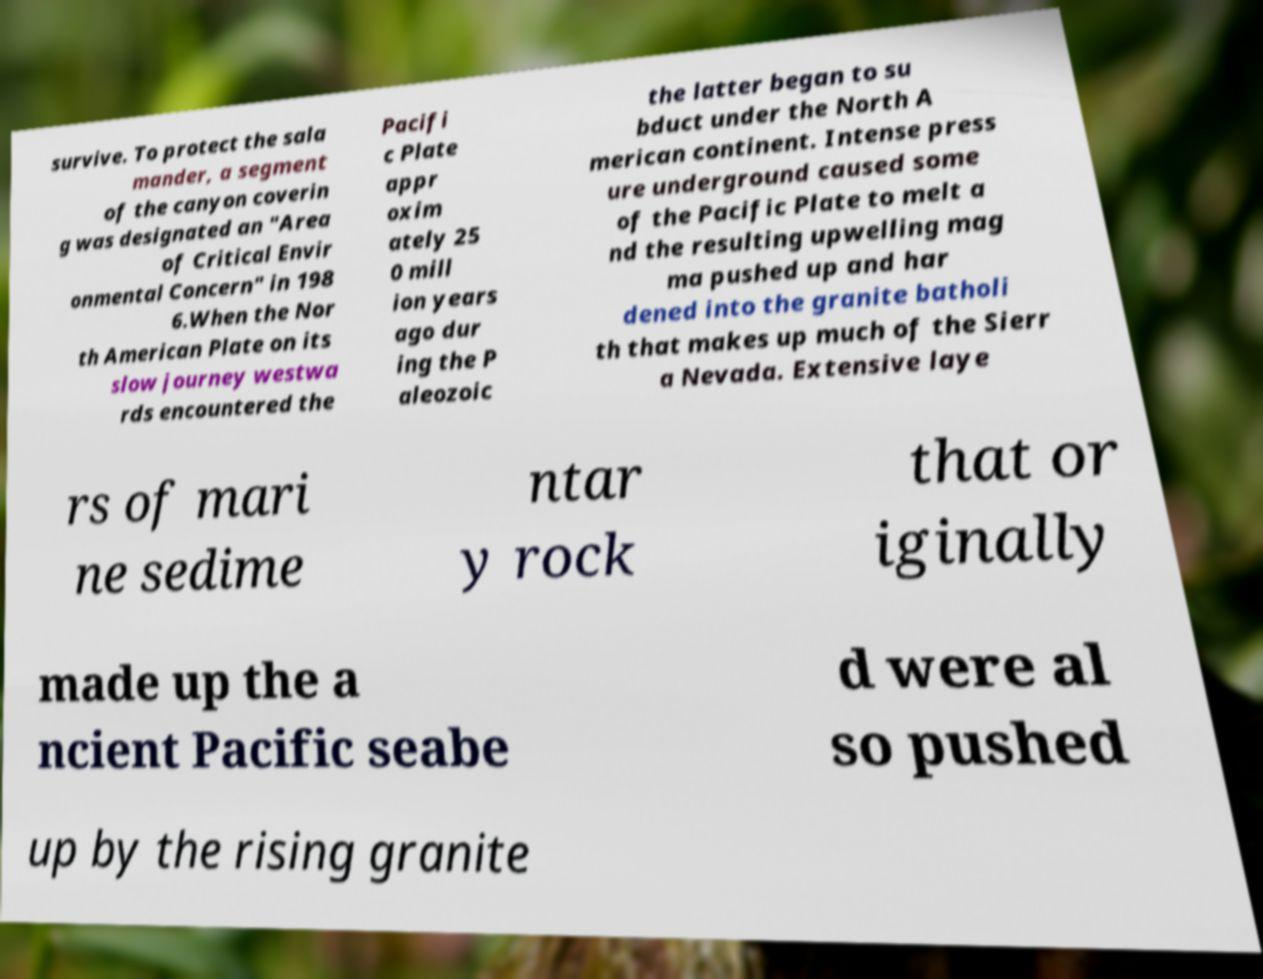Can you accurately transcribe the text from the provided image for me? survive. To protect the sala mander, a segment of the canyon coverin g was designated an "Area of Critical Envir onmental Concern" in 198 6.When the Nor th American Plate on its slow journey westwa rds encountered the Pacifi c Plate appr oxim ately 25 0 mill ion years ago dur ing the P aleozoic the latter began to su bduct under the North A merican continent. Intense press ure underground caused some of the Pacific Plate to melt a nd the resulting upwelling mag ma pushed up and har dened into the granite batholi th that makes up much of the Sierr a Nevada. Extensive laye rs of mari ne sedime ntar y rock that or iginally made up the a ncient Pacific seabe d were al so pushed up by the rising granite 